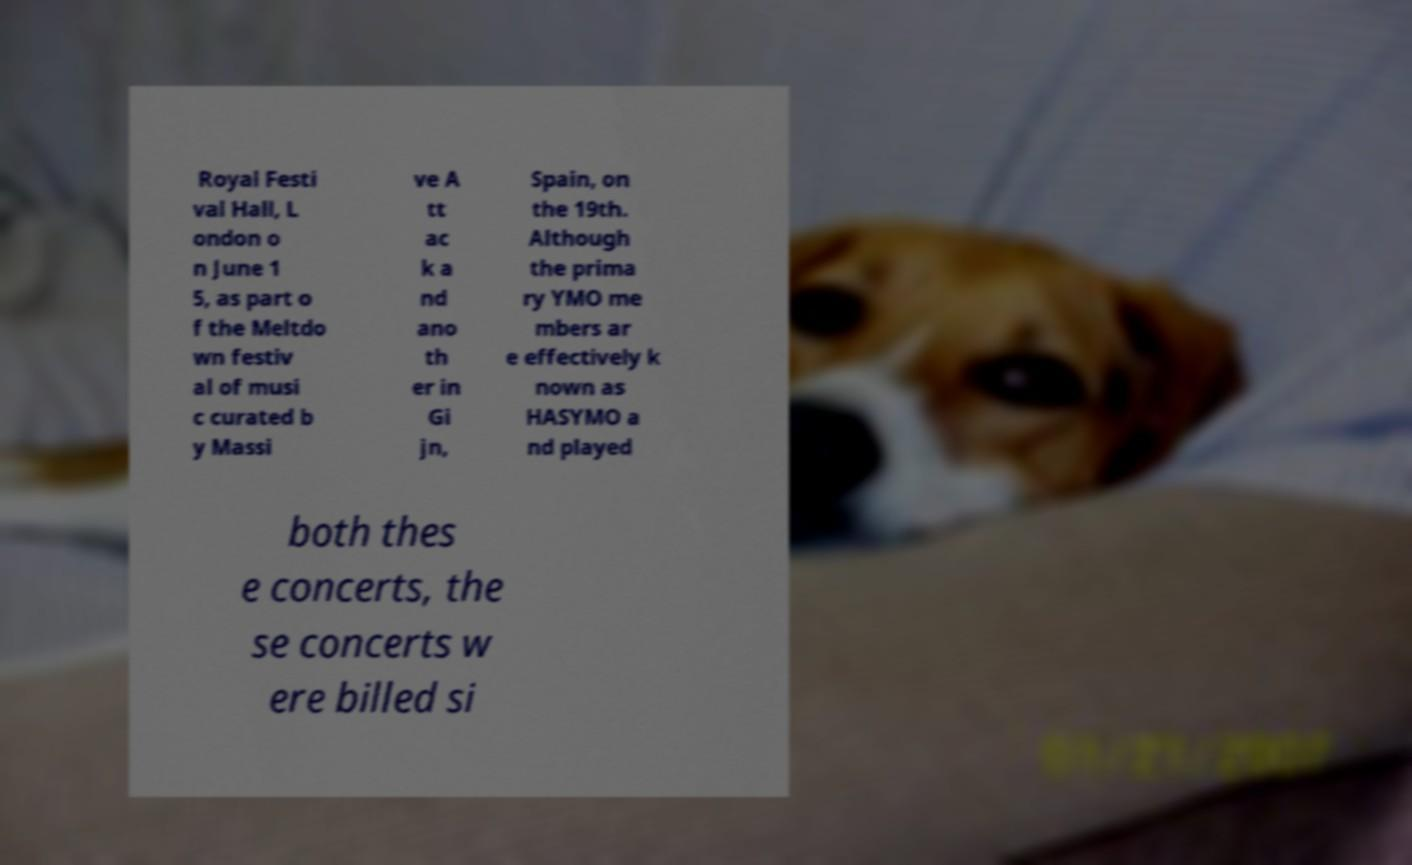For documentation purposes, I need the text within this image transcribed. Could you provide that? Royal Festi val Hall, L ondon o n June 1 5, as part o f the Meltdo wn festiv al of musi c curated b y Massi ve A tt ac k a nd ano th er in Gi jn, Spain, on the 19th. Although the prima ry YMO me mbers ar e effectively k nown as HASYMO a nd played both thes e concerts, the se concerts w ere billed si 